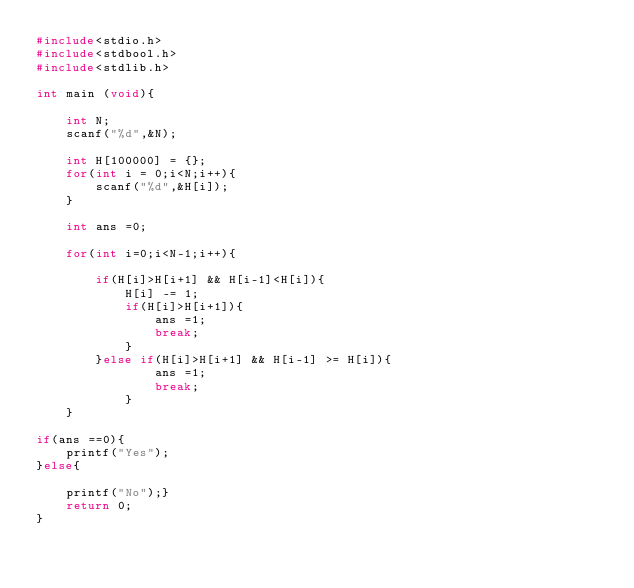<code> <loc_0><loc_0><loc_500><loc_500><_C_>#include<stdio.h>
#include<stdbool.h>
#include<stdlib.h>

int main (void){

    int N;
    scanf("%d",&N);

    int H[100000] = {};
    for(int i = 0;i<N;i++){
        scanf("%d",&H[i]);
    }

    int ans =0;

    for(int i=0;i<N-1;i++){
        
        if(H[i]>H[i+1] && H[i-1]<H[i]){
            H[i] -= 1;
            if(H[i]>H[i+1]){
                ans =1;
                break;
            }
        }else if(H[i]>H[i+1] && H[i-1] >= H[i]){
                ans =1;
                break;
            }
    }
    
if(ans ==0){
    printf("Yes");
}else{

    printf("No");}
    return 0;
}

</code> 